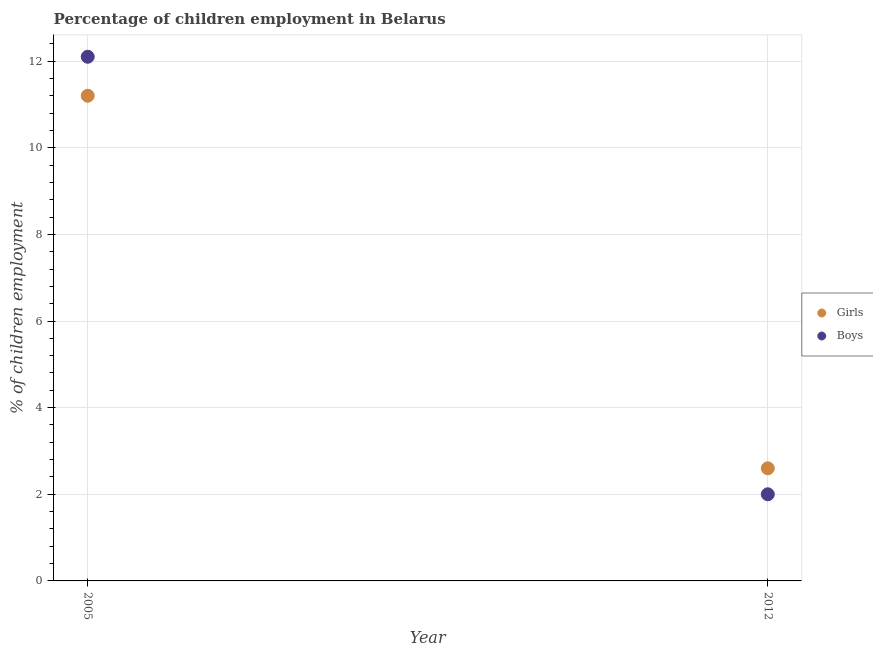Is the number of dotlines equal to the number of legend labels?
Your response must be concise. Yes. What is the percentage of employed girls in 2005?
Your response must be concise. 11.2. In which year was the percentage of employed girls minimum?
Your answer should be very brief. 2012. What is the total percentage of employed girls in the graph?
Provide a short and direct response. 13.8. What is the average percentage of employed boys per year?
Ensure brevity in your answer.  7.05. In the year 2012, what is the difference between the percentage of employed boys and percentage of employed girls?
Offer a very short reply. -0.6. What is the ratio of the percentage of employed girls in 2005 to that in 2012?
Keep it short and to the point. 4.31. Is the percentage of employed boys in 2005 less than that in 2012?
Offer a very short reply. No. Is the percentage of employed girls strictly greater than the percentage of employed boys over the years?
Provide a succinct answer. No. How many dotlines are there?
Your answer should be very brief. 2. How many years are there in the graph?
Your response must be concise. 2. What is the difference between two consecutive major ticks on the Y-axis?
Give a very brief answer. 2. Are the values on the major ticks of Y-axis written in scientific E-notation?
Your answer should be very brief. No. How many legend labels are there?
Keep it short and to the point. 2. What is the title of the graph?
Provide a short and direct response. Percentage of children employment in Belarus. Does "Male labourers" appear as one of the legend labels in the graph?
Your answer should be very brief. No. What is the label or title of the X-axis?
Keep it short and to the point. Year. What is the label or title of the Y-axis?
Your response must be concise. % of children employment. What is the % of children employment of Boys in 2005?
Keep it short and to the point. 12.1. What is the % of children employment in Girls in 2012?
Give a very brief answer. 2.6. What is the % of children employment of Boys in 2012?
Make the answer very short. 2. Across all years, what is the maximum % of children employment in Girls?
Keep it short and to the point. 11.2. Across all years, what is the maximum % of children employment in Boys?
Provide a short and direct response. 12.1. Across all years, what is the minimum % of children employment in Girls?
Provide a short and direct response. 2.6. Across all years, what is the minimum % of children employment of Boys?
Your answer should be very brief. 2. What is the total % of children employment in Boys in the graph?
Keep it short and to the point. 14.1. What is the difference between the % of children employment of Girls in 2005 and that in 2012?
Offer a very short reply. 8.6. What is the difference between the % of children employment of Boys in 2005 and that in 2012?
Your answer should be very brief. 10.1. What is the difference between the % of children employment of Girls in 2005 and the % of children employment of Boys in 2012?
Ensure brevity in your answer.  9.2. What is the average % of children employment in Girls per year?
Make the answer very short. 6.9. What is the average % of children employment of Boys per year?
Keep it short and to the point. 7.05. In the year 2012, what is the difference between the % of children employment of Girls and % of children employment of Boys?
Make the answer very short. 0.6. What is the ratio of the % of children employment in Girls in 2005 to that in 2012?
Offer a terse response. 4.31. What is the ratio of the % of children employment in Boys in 2005 to that in 2012?
Offer a very short reply. 6.05. What is the difference between the highest and the lowest % of children employment in Girls?
Your response must be concise. 8.6. 